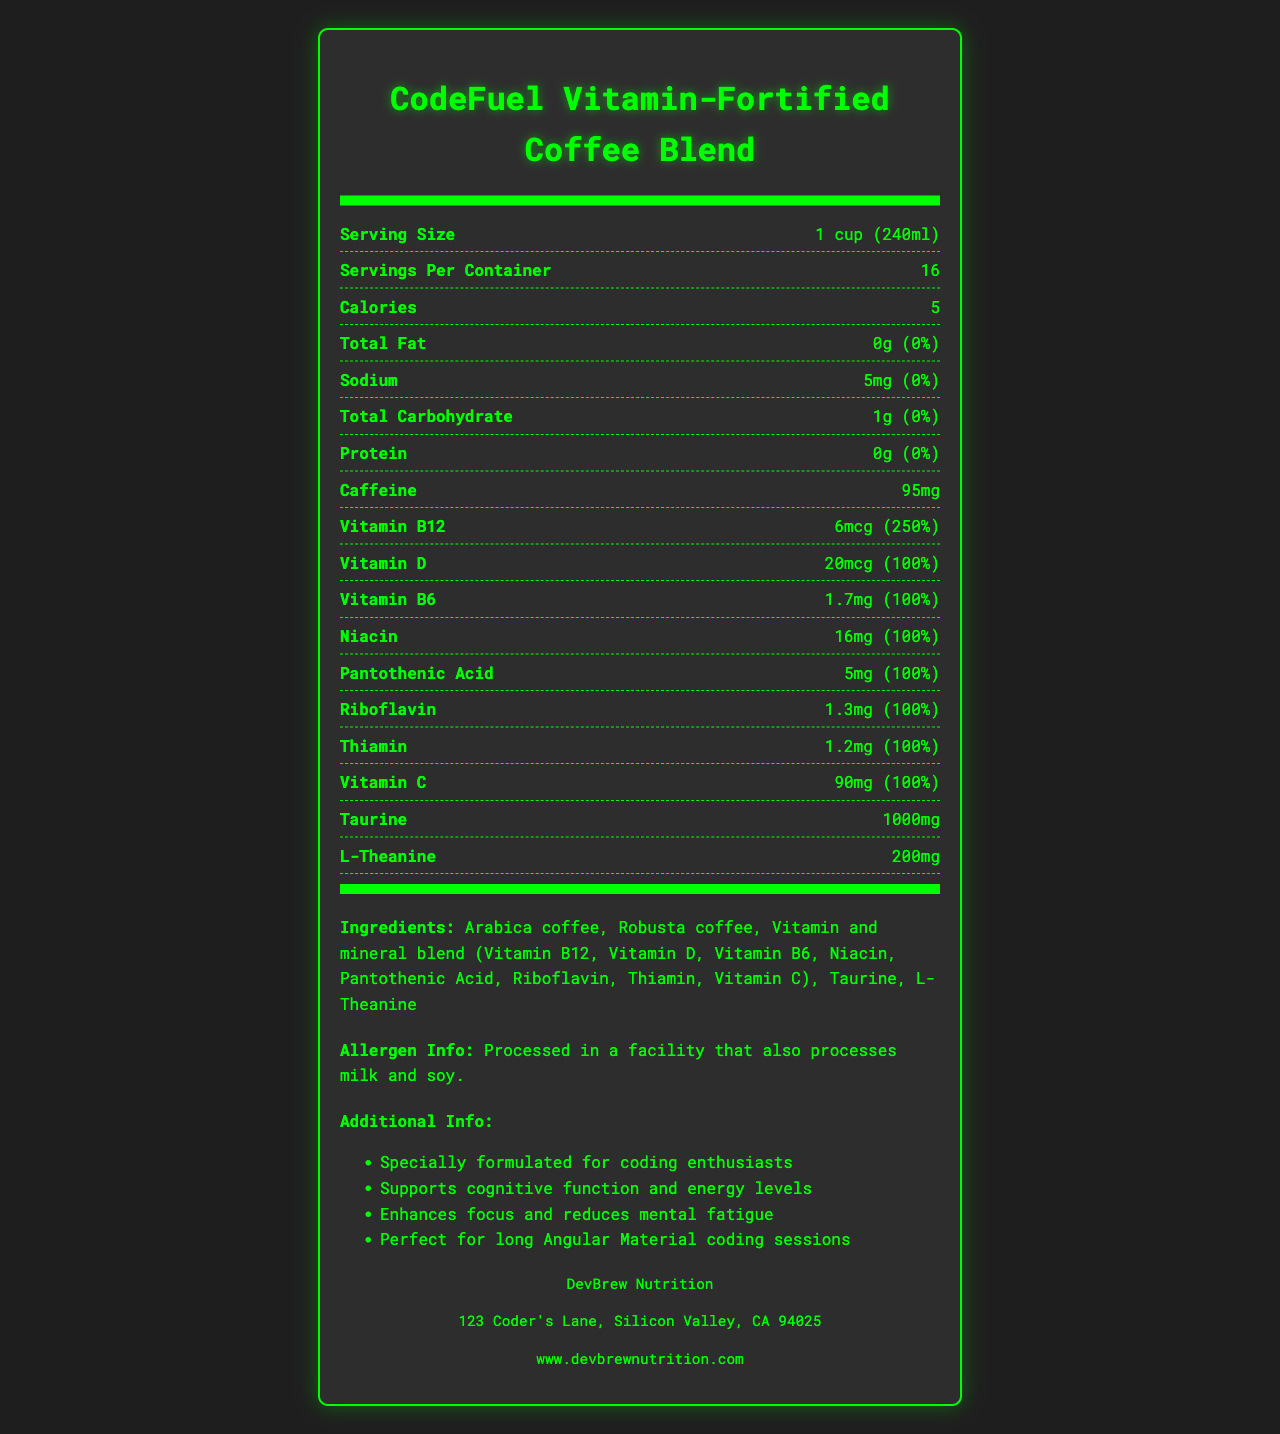What is the serving size of CodeFuel Vitamin-Fortified Coffee Blend? The serving size is listed at the beginning of the nutrition facts section as "1 cup (240ml)".
Answer: 1 cup (240ml) How many calories are in one serving? The calories per serving are stated in the nutrition facts section as "Calories: 5".
Answer: 5 calories How much sodium is in a serving, and what percentage of the daily value does this represent? The nutrition facts section lists Sodium as "5mg (0%)".
Answer: 5mg, 0% How much caffeine is in a serving? The amount of caffeine per serving is mentioned in the nutrition facts section as "Caffeine: 95mg".
Answer: 95mg What percentage of the daily value of Vitamin B12 does one serving provide? The nutrition facts section lists the Vitamin B12 amount as "6mcg (250%)".
Answer: 250% Is there any fat in this coffee blend? The nutrition facts section mentions "Total Fat: 0g (0%)", indicating there is no fat.
Answer: No Which vitamin is provided at 100% of the daily value in a serving? The nutrition facts list several vitamins (Vitamin D, Vitamin B6, Niacin, Pantothenic Acid, Riboflavin, Thiamin, and Vitamin C) each providing 100% of the daily value.
Answer: Vitamin D, Vitamin B6, Niacin, Pantothenic Acid, Riboflavin, Thiamin, Vitamin C How many servings are in one container of CodeFuel Vitamin-Fortified Coffee Blend? The number of servings per container is listed as "Servings Per Container: 16".
Answer: 16 Which of the following is NOT listed as an ingredient in this coffee blend? A. Taurine B. L-Theanine C. Sugar The ingredients listed are Arabica coffee, Robusta coffee, Vitamin and mineral blend, Taurine, and L-Theanine. Sugar is not mentioned.
Answer: C. Sugar What additional benefits are mentioned for coding enthusiasts? The additional info section lists benefits like "Supports cognitive function and energy levels", "Enhances focus and reduces mental fatigue", and "Perfect for long Angular Material coding sessions".
Answer: Supports cognitive function and energy levels, Enhances focus and reduces mental fatigue, Perfect for long Angular Material coding sessions Does this coffee blend contain any allergens? The allergen info states, "Processed in a facility that also processes milk and soy."
Answer: Yes Summarize the main idea of the document The document outlines the nutritional content, ingredients, special benefits for coders, allergen information, and manufacturer details of CodeFuel Vitamin-Fortified Coffee Blend, emphasizing its support for cognitive function and energy.
Answer: The document provides detailed nutritional information and additional information about CodeFuel Vitamin-Fortified Coffee Blend, a coffee specially formulated for coding enthusiasts to support cognitive function, energy levels, focus, and reduce mental fatigue. It includes ingredients, serving size, vitamins, minerals, caffeine content, and manufacturer details. How much taurine is in a serving of this coffee blend? The nutrition facts section lists Taurine content as "1000mg".
Answer: 1000mg Where is DevBrew Nutrition located? The manufacturer info section mentions the address as "123 Coder's Lane, Silicon Valley, CA 94025".
Answer: 123 Coder's Lane, Silicon Valley, CA 94025 How many grams of protein does each serving contain? The nutrition facts section states "Protein: 0g (0%)".
Answer: 0g Can I find information about the availability of this product in stores? The document does not provide information about the product's availability in stores.
Answer: Not enough information 